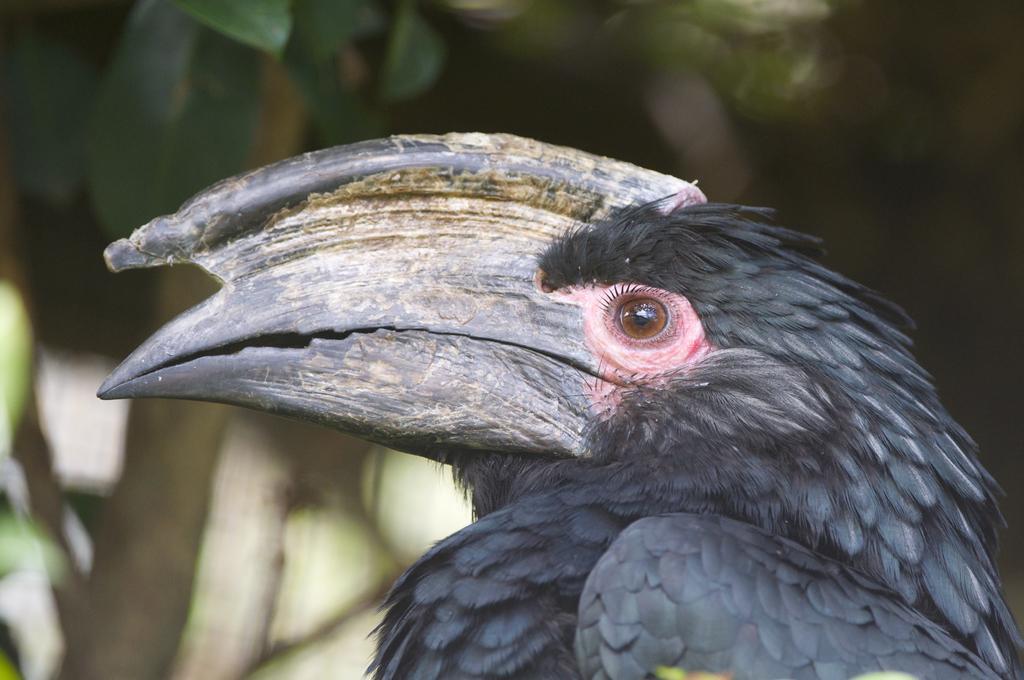Can you describe this image briefly? In this image, I can see a bird named as Hornbill. This bird is black in color. The background looks blurry. 